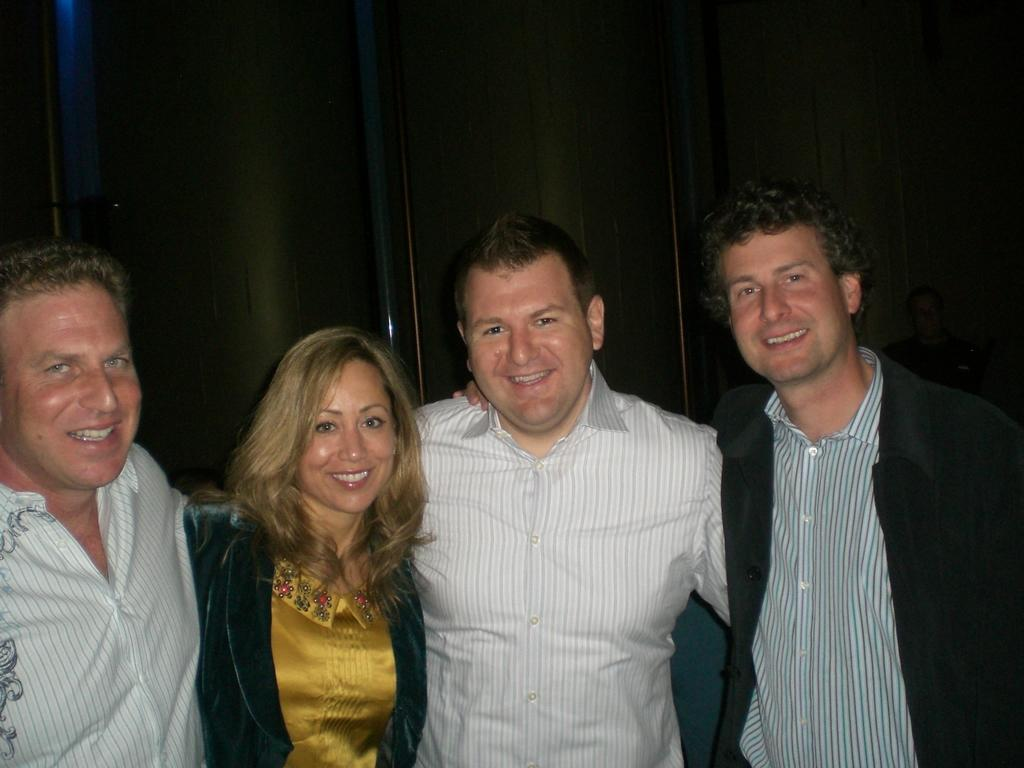What is happening in the middle of the image? There are people standing in the middle of the image. How are the people in the image feeling? The people are smiling in the image. What can be seen in the background of the image? There is a wall in the background of the image. What type of breath can be seen coming from the people in the image? There is no visible breath in the image, as it is not cold enough to produce visible breath. Can you tell me how many trucks are parked behind the wall in the image? There is no truck visible in the image; only the people and the wall are present. 